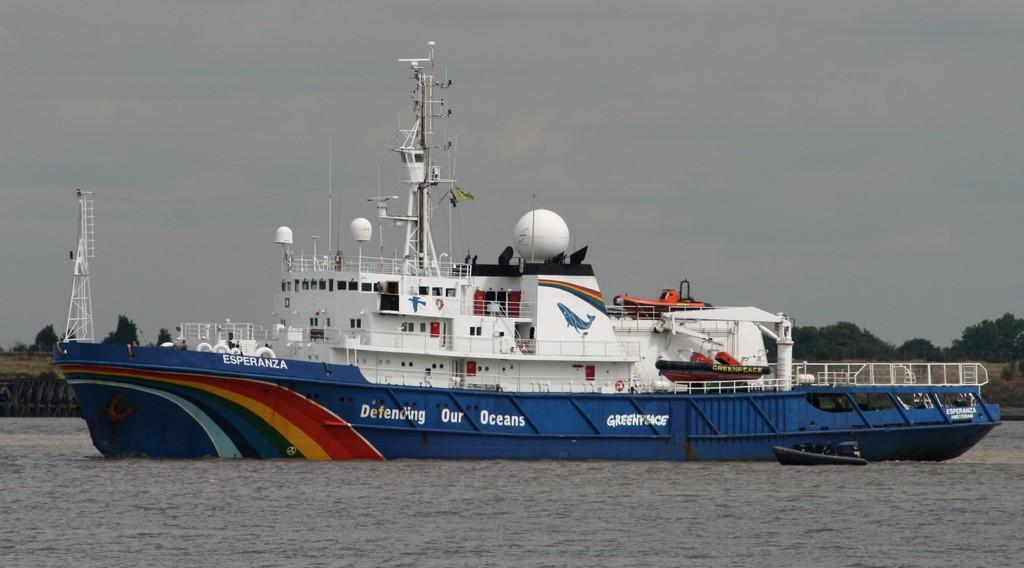<image>
Summarize the visual content of the image. The blue ship Esperanza is defending our oceans. 